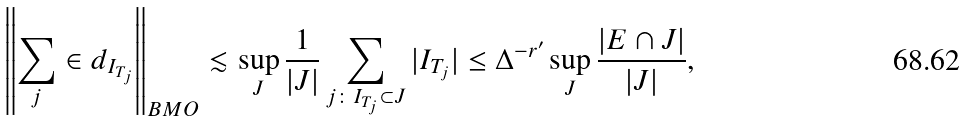Convert formula to latex. <formula><loc_0><loc_0><loc_500><loc_500>\left \| \sum _ { j } \in d _ { I _ { T _ { j } } } \right \| _ { B M O } \lesssim \sup _ { J } \frac { 1 } { | J | } \sum _ { j \colon I _ { T _ { j } } \subset J } | I _ { T _ { j } } | \leq \Delta ^ { - r ^ { \prime } } \sup _ { J } \frac { | E \cap J | } { | J | } ,</formula> 